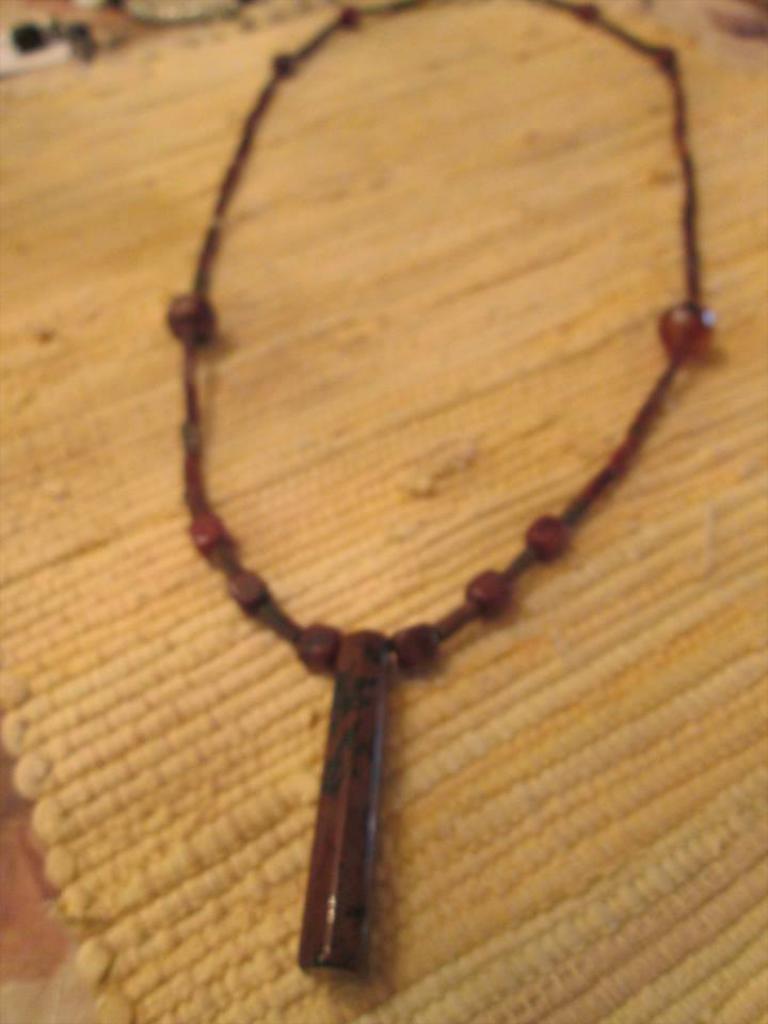Please provide a concise description of this image. In this picture I can see there is a chain and it has a locket. It is placed on a yellow colored surface. 